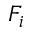Convert formula to latex. <formula><loc_0><loc_0><loc_500><loc_500>F _ { i }</formula> 